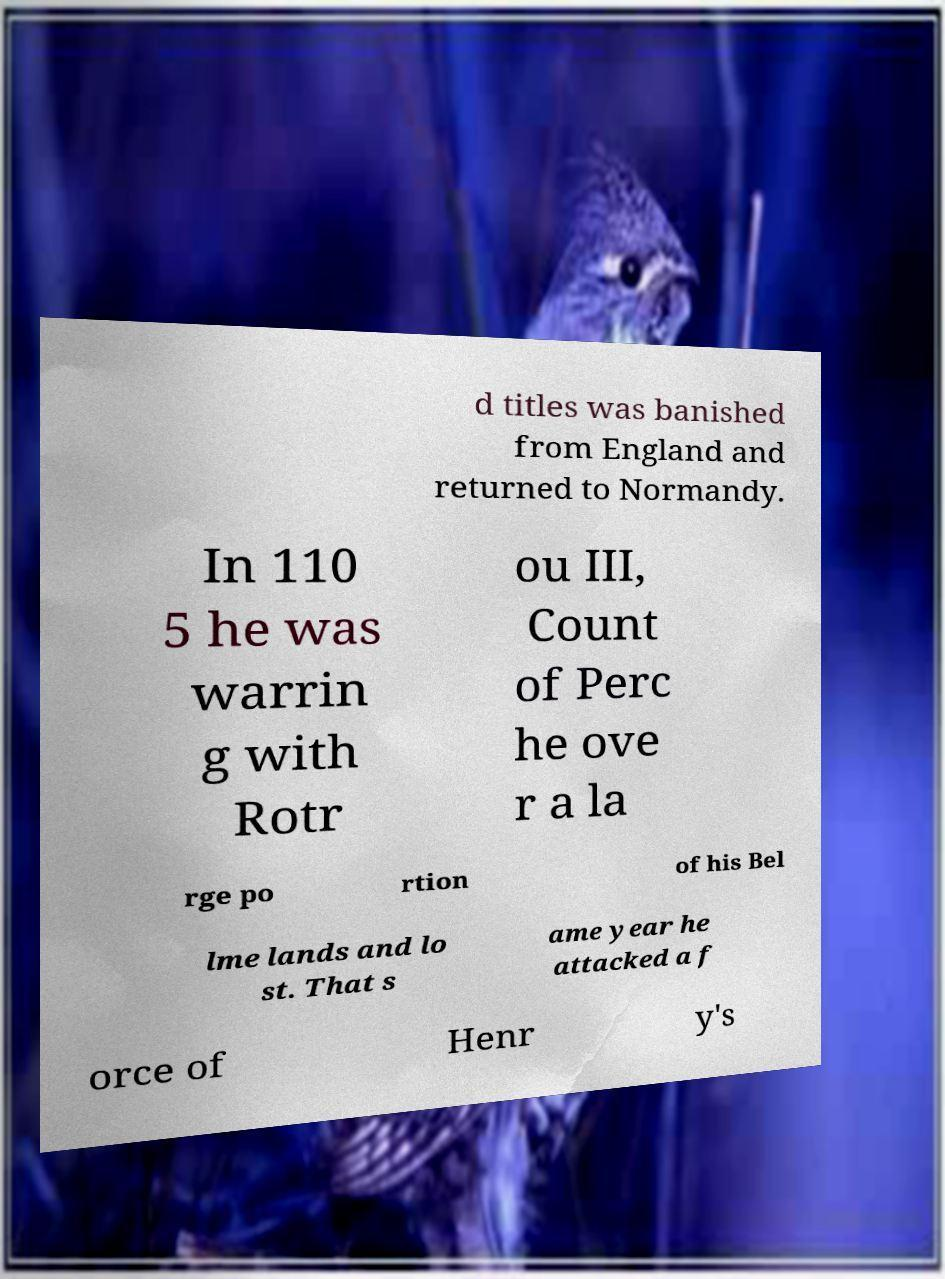I need the written content from this picture converted into text. Can you do that? d titles was banished from England and returned to Normandy. In 110 5 he was warrin g with Rotr ou III, Count of Perc he ove r a la rge po rtion of his Bel lme lands and lo st. That s ame year he attacked a f orce of Henr y's 